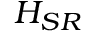<formula> <loc_0><loc_0><loc_500><loc_500>H _ { S R }</formula> 